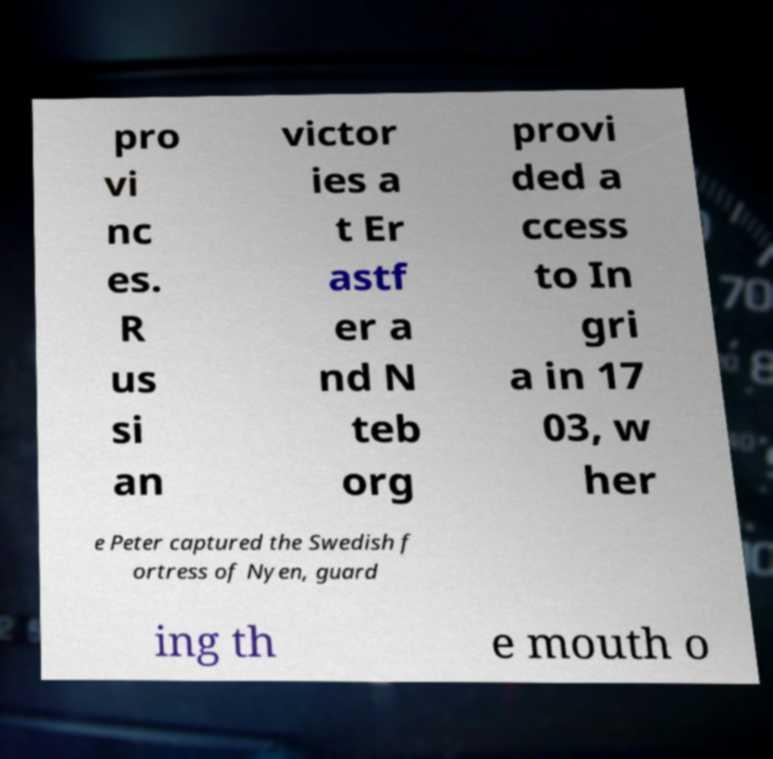Please read and relay the text visible in this image. What does it say? pro vi nc es. R us si an victor ies a t Er astf er a nd N teb org provi ded a ccess to In gri a in 17 03, w her e Peter captured the Swedish f ortress of Nyen, guard ing th e mouth o 